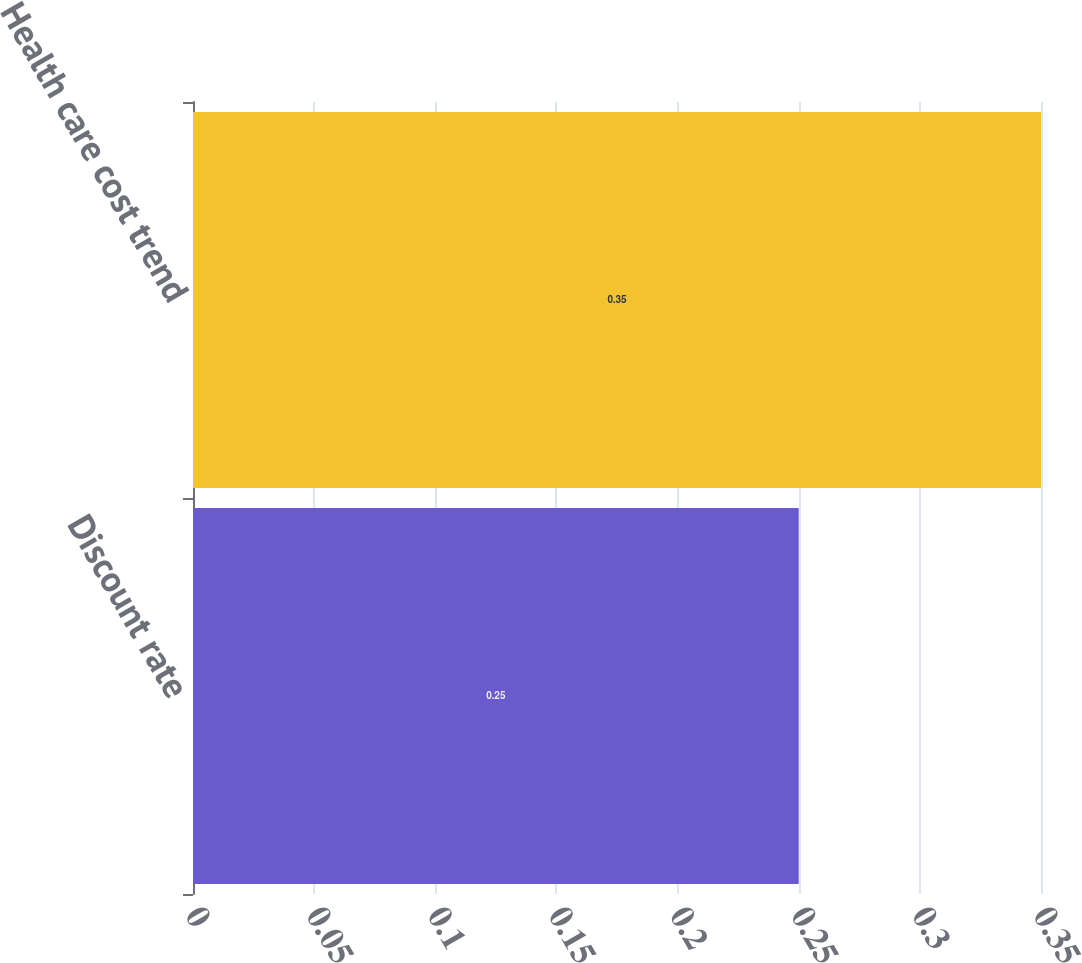<chart> <loc_0><loc_0><loc_500><loc_500><bar_chart><fcel>Discount rate<fcel>Health care cost trend<nl><fcel>0.25<fcel>0.35<nl></chart> 